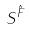Convert formula to latex. <formula><loc_0><loc_0><loc_500><loc_500>S ^ { \hat { F } }</formula> 